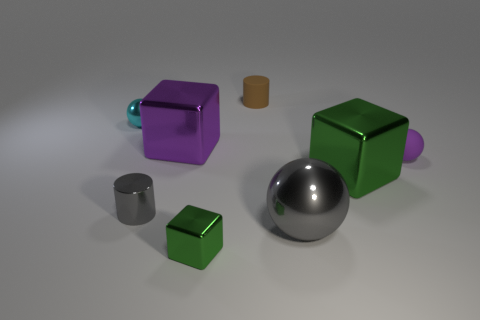Add 1 big green things. How many objects exist? 9 Subtract all blocks. How many objects are left? 5 Add 3 gray metallic things. How many gray metallic things are left? 5 Add 8 brown matte cylinders. How many brown matte cylinders exist? 9 Subtract 0 cyan cylinders. How many objects are left? 8 Subtract all small gray matte things. Subtract all large shiny spheres. How many objects are left? 7 